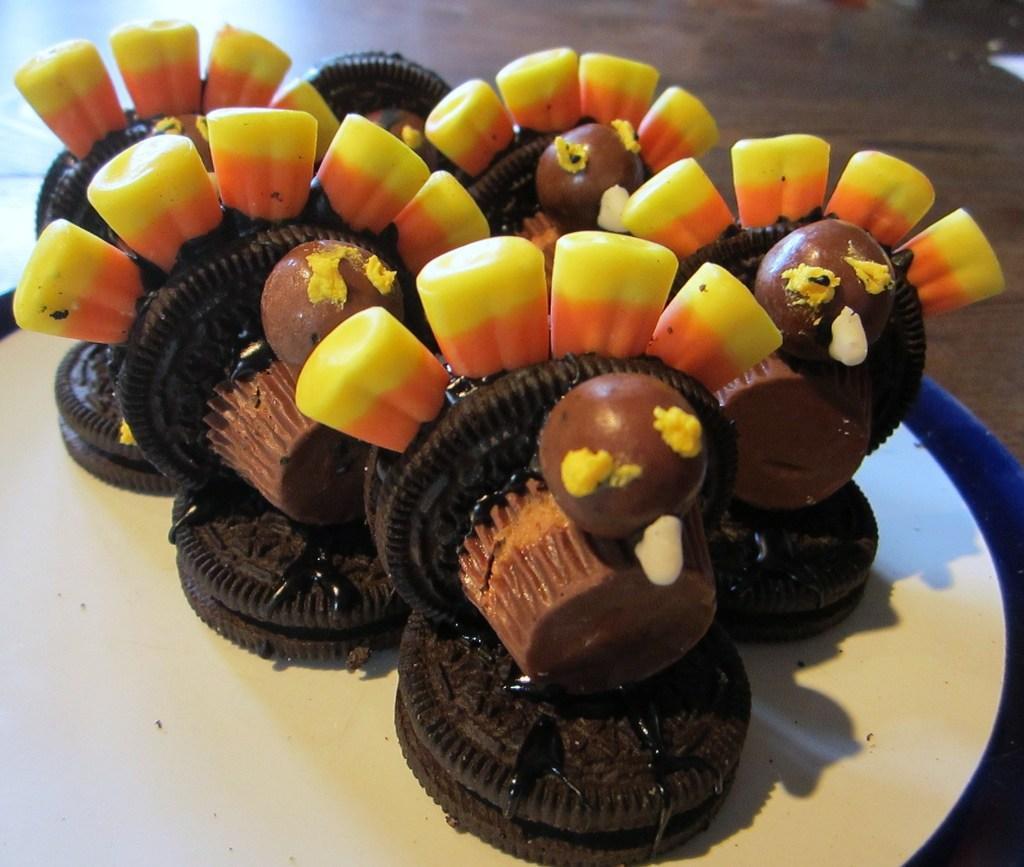Describe this image in one or two sentences. In this image we can see biscuits on the table, there are the cupcakes, chocolate balls. 